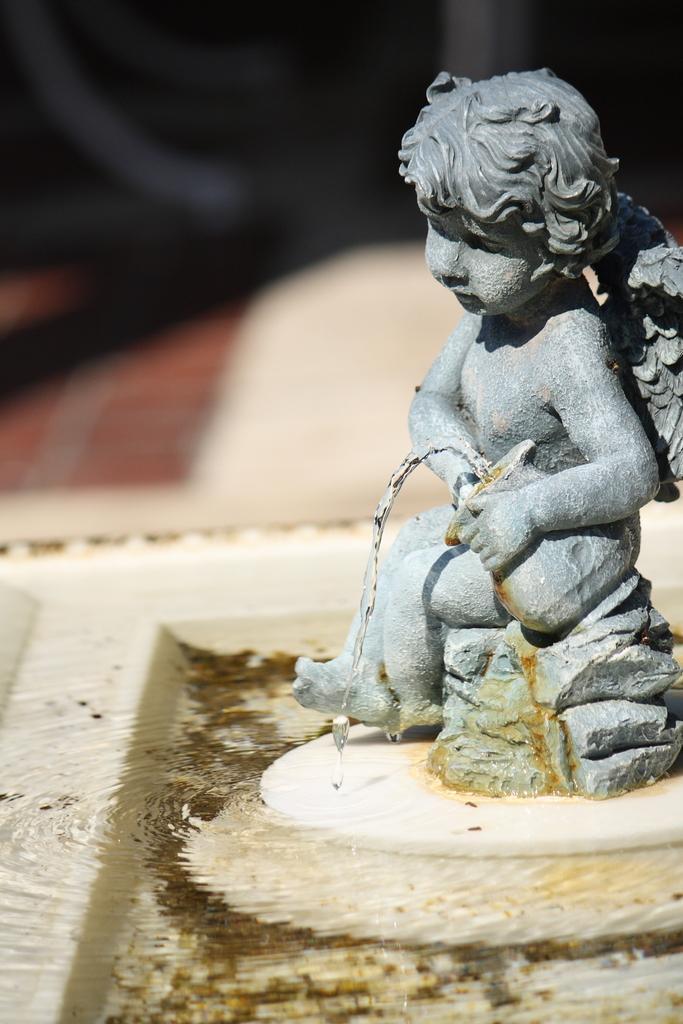Describe this image in one or two sentences. This image is taken outdoors. At the bottom of the image there is a fountain. On the right side of the image there is a sculpture. 